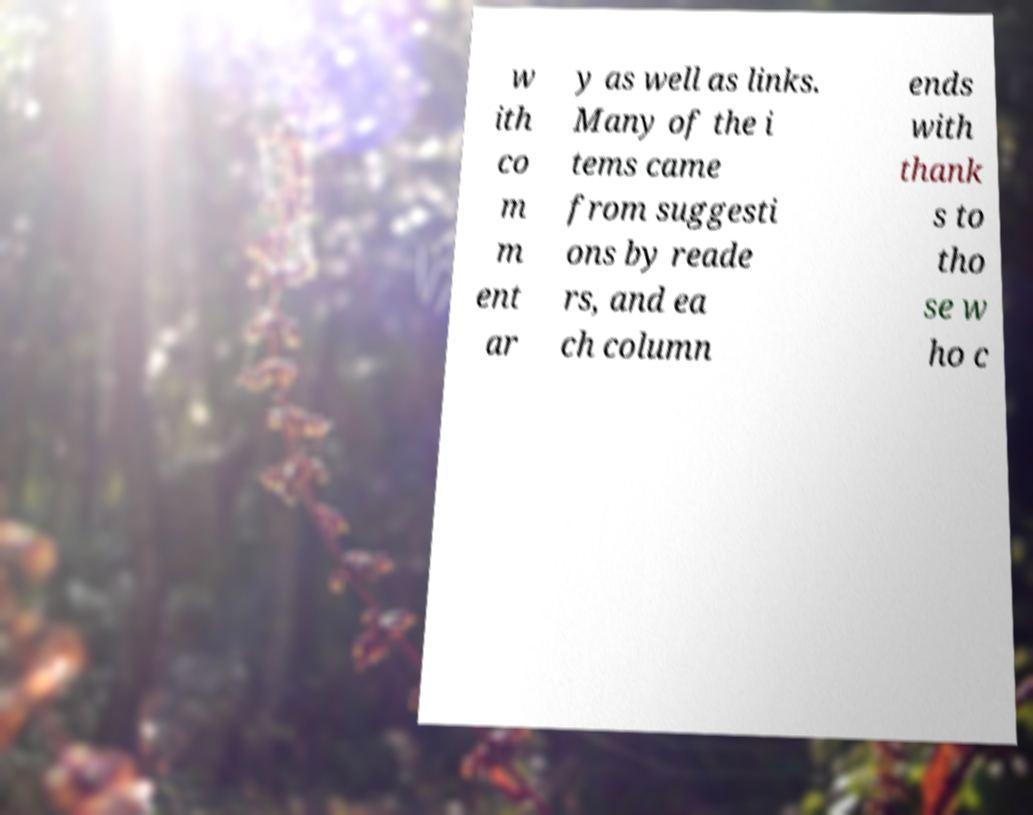Could you assist in decoding the text presented in this image and type it out clearly? w ith co m m ent ar y as well as links. Many of the i tems came from suggesti ons by reade rs, and ea ch column ends with thank s to tho se w ho c 